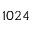<formula> <loc_0><loc_0><loc_500><loc_500>1 0 2 4</formula> 